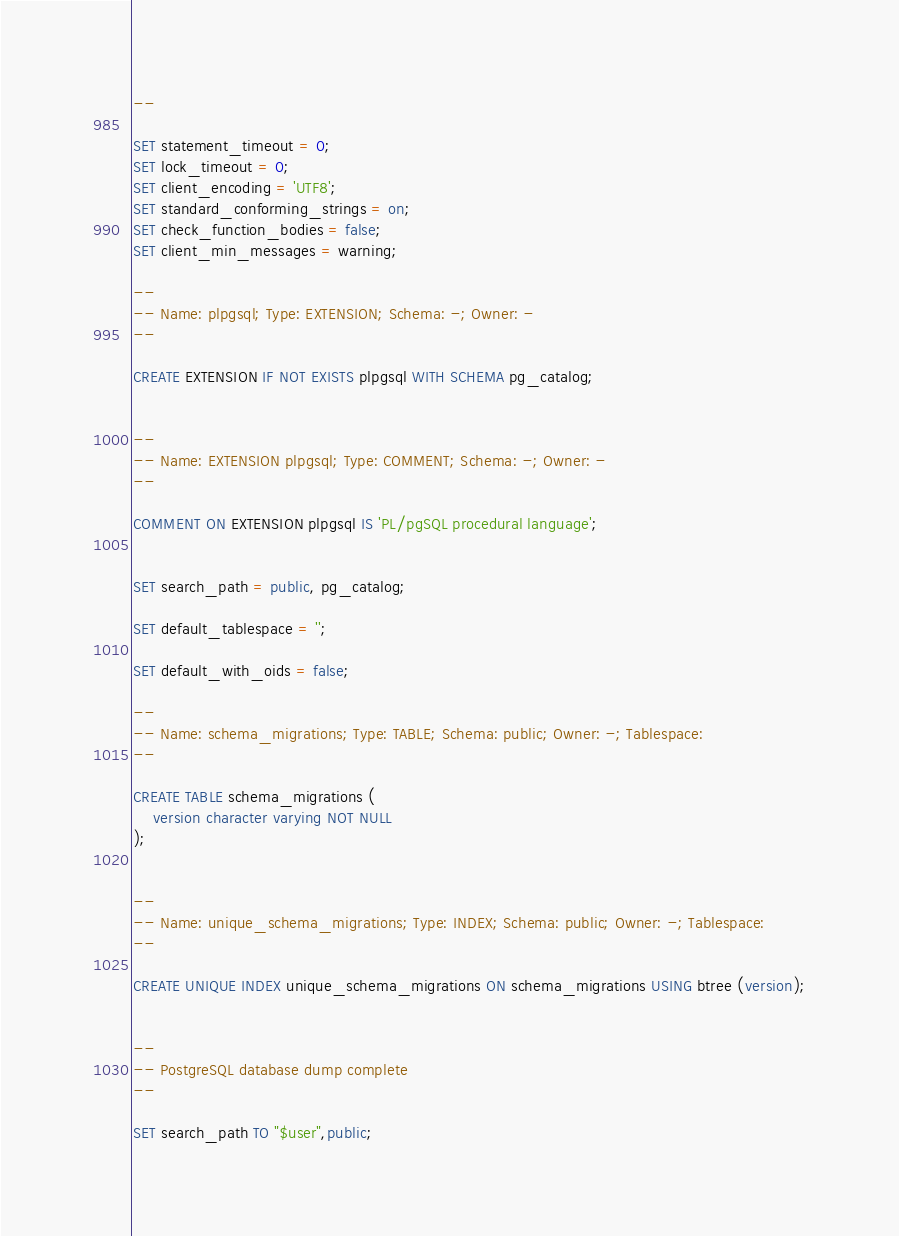<code> <loc_0><loc_0><loc_500><loc_500><_SQL_>--

SET statement_timeout = 0;
SET lock_timeout = 0;
SET client_encoding = 'UTF8';
SET standard_conforming_strings = on;
SET check_function_bodies = false;
SET client_min_messages = warning;

--
-- Name: plpgsql; Type: EXTENSION; Schema: -; Owner: -
--

CREATE EXTENSION IF NOT EXISTS plpgsql WITH SCHEMA pg_catalog;


--
-- Name: EXTENSION plpgsql; Type: COMMENT; Schema: -; Owner: -
--

COMMENT ON EXTENSION plpgsql IS 'PL/pgSQL procedural language';


SET search_path = public, pg_catalog;

SET default_tablespace = '';

SET default_with_oids = false;

--
-- Name: schema_migrations; Type: TABLE; Schema: public; Owner: -; Tablespace: 
--

CREATE TABLE schema_migrations (
    version character varying NOT NULL
);


--
-- Name: unique_schema_migrations; Type: INDEX; Schema: public; Owner: -; Tablespace: 
--

CREATE UNIQUE INDEX unique_schema_migrations ON schema_migrations USING btree (version);


--
-- PostgreSQL database dump complete
--

SET search_path TO "$user",public;



</code> 